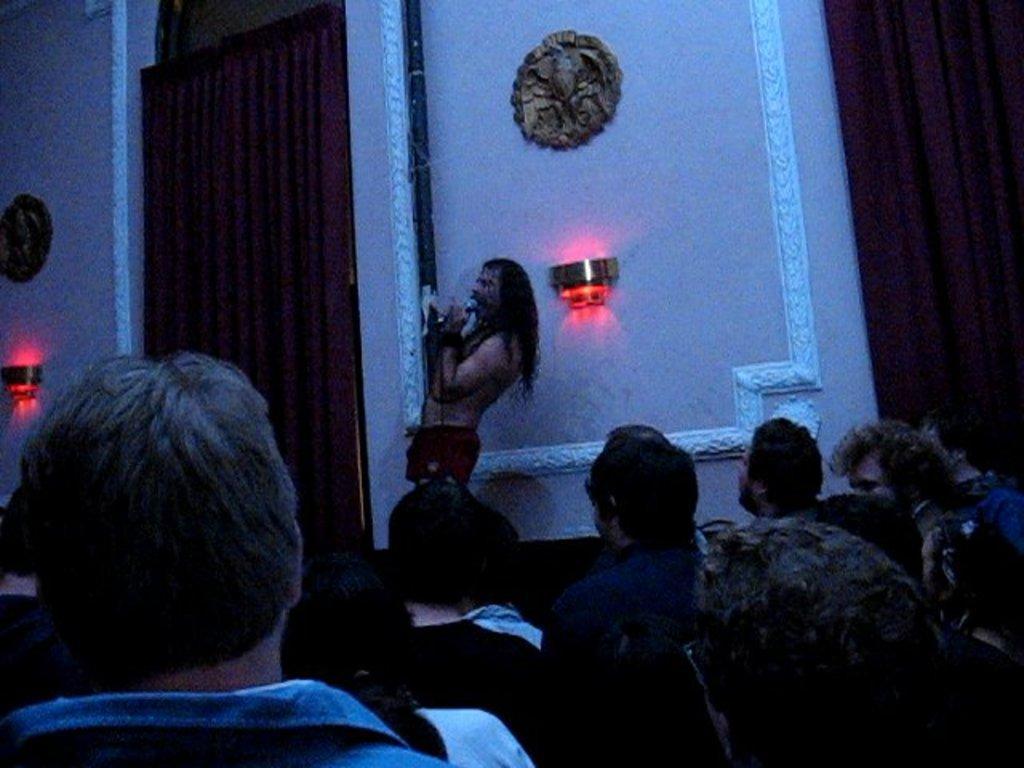How would you summarize this image in a sentence or two? In the foreground of the picture there are people standing. In the center of the picture there is a man holding a mic. In the background there are curtains, light, frames and wall painted white. 